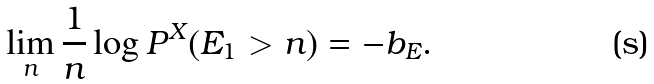Convert formula to latex. <formula><loc_0><loc_0><loc_500><loc_500>\lim _ { n } \frac { 1 } { n } \log P ^ { X } ( E _ { 1 } > n ) = - b _ { E } .</formula> 